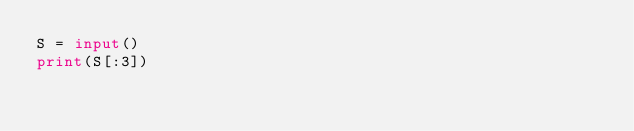<code> <loc_0><loc_0><loc_500><loc_500><_Python_>S = input()
print(S[:3])</code> 